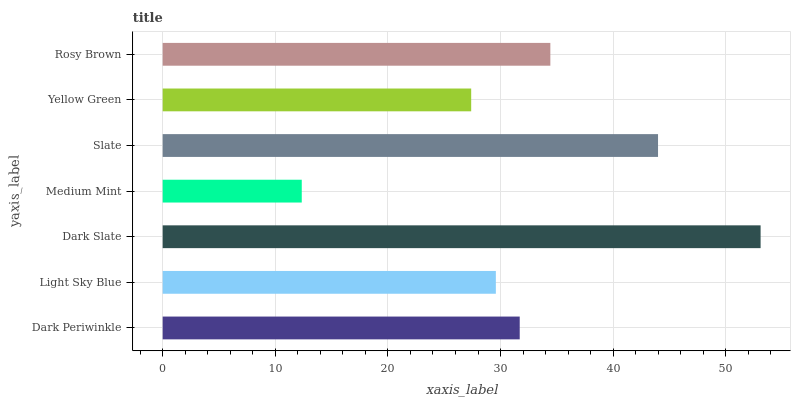Is Medium Mint the minimum?
Answer yes or no. Yes. Is Dark Slate the maximum?
Answer yes or no. Yes. Is Light Sky Blue the minimum?
Answer yes or no. No. Is Light Sky Blue the maximum?
Answer yes or no. No. Is Dark Periwinkle greater than Light Sky Blue?
Answer yes or no. Yes. Is Light Sky Blue less than Dark Periwinkle?
Answer yes or no. Yes. Is Light Sky Blue greater than Dark Periwinkle?
Answer yes or no. No. Is Dark Periwinkle less than Light Sky Blue?
Answer yes or no. No. Is Dark Periwinkle the high median?
Answer yes or no. Yes. Is Dark Periwinkle the low median?
Answer yes or no. Yes. Is Light Sky Blue the high median?
Answer yes or no. No. Is Medium Mint the low median?
Answer yes or no. No. 